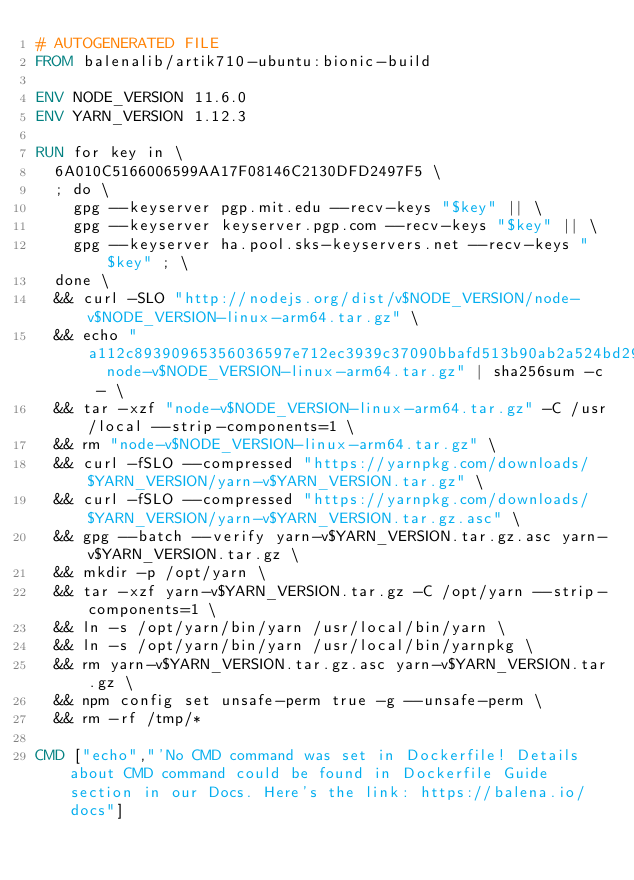Convert code to text. <code><loc_0><loc_0><loc_500><loc_500><_Dockerfile_># AUTOGENERATED FILE
FROM balenalib/artik710-ubuntu:bionic-build

ENV NODE_VERSION 11.6.0
ENV YARN_VERSION 1.12.3

RUN for key in \
	6A010C5166006599AA17F08146C2130DFD2497F5 \
	; do \
		gpg --keyserver pgp.mit.edu --recv-keys "$key" || \
		gpg --keyserver keyserver.pgp.com --recv-keys "$key" || \
		gpg --keyserver ha.pool.sks-keyservers.net --recv-keys "$key" ; \
	done \
	&& curl -SLO "http://nodejs.org/dist/v$NODE_VERSION/node-v$NODE_VERSION-linux-arm64.tar.gz" \
	&& echo "a112c89390965356036597e712ec3939c37090bbafd513b90ab2a524bd29190a  node-v$NODE_VERSION-linux-arm64.tar.gz" | sha256sum -c - \
	&& tar -xzf "node-v$NODE_VERSION-linux-arm64.tar.gz" -C /usr/local --strip-components=1 \
	&& rm "node-v$NODE_VERSION-linux-arm64.tar.gz" \
	&& curl -fSLO --compressed "https://yarnpkg.com/downloads/$YARN_VERSION/yarn-v$YARN_VERSION.tar.gz" \
	&& curl -fSLO --compressed "https://yarnpkg.com/downloads/$YARN_VERSION/yarn-v$YARN_VERSION.tar.gz.asc" \
	&& gpg --batch --verify yarn-v$YARN_VERSION.tar.gz.asc yarn-v$YARN_VERSION.tar.gz \
	&& mkdir -p /opt/yarn \
	&& tar -xzf yarn-v$YARN_VERSION.tar.gz -C /opt/yarn --strip-components=1 \
	&& ln -s /opt/yarn/bin/yarn /usr/local/bin/yarn \
	&& ln -s /opt/yarn/bin/yarn /usr/local/bin/yarnpkg \
	&& rm yarn-v$YARN_VERSION.tar.gz.asc yarn-v$YARN_VERSION.tar.gz \
	&& npm config set unsafe-perm true -g --unsafe-perm \
	&& rm -rf /tmp/*

CMD ["echo","'No CMD command was set in Dockerfile! Details about CMD command could be found in Dockerfile Guide section in our Docs. Here's the link: https://balena.io/docs"]</code> 